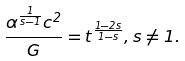Convert formula to latex. <formula><loc_0><loc_0><loc_500><loc_500>\frac { \alpha ^ { \frac { 1 } { s - 1 } } c ^ { 2 } } { G } = t ^ { \frac { 1 - 2 s } { 1 - s } } , s \neq 1 .</formula> 